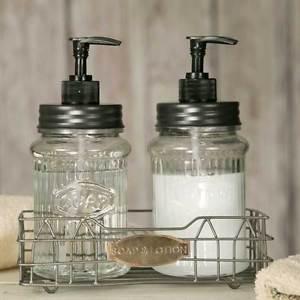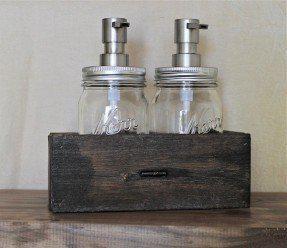The first image is the image on the left, the second image is the image on the right. Analyze the images presented: Is the assertion "At least one bottle dispenser is facing left." valid? Answer yes or no. No. The first image is the image on the left, the second image is the image on the right. Given the left and right images, does the statement "Each image shows a carrier holding two pump-top jars." hold true? Answer yes or no. Yes. 